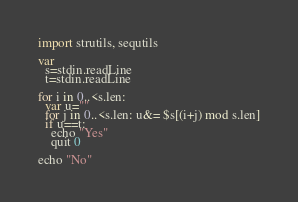Convert code to text. <code><loc_0><loc_0><loc_500><loc_500><_Nim_>import strutils, sequtils

var
  s=stdin.readLine
  t=stdin.readLine

for i in 0..<s.len:
  var u=""
  for j in 0..<s.len: u&= $s[(i+j) mod s.len]
  if u==t:
    echo "Yes"
    quit 0

echo "No"</code> 